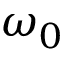Convert formula to latex. <formula><loc_0><loc_0><loc_500><loc_500>\omega _ { 0 }</formula> 